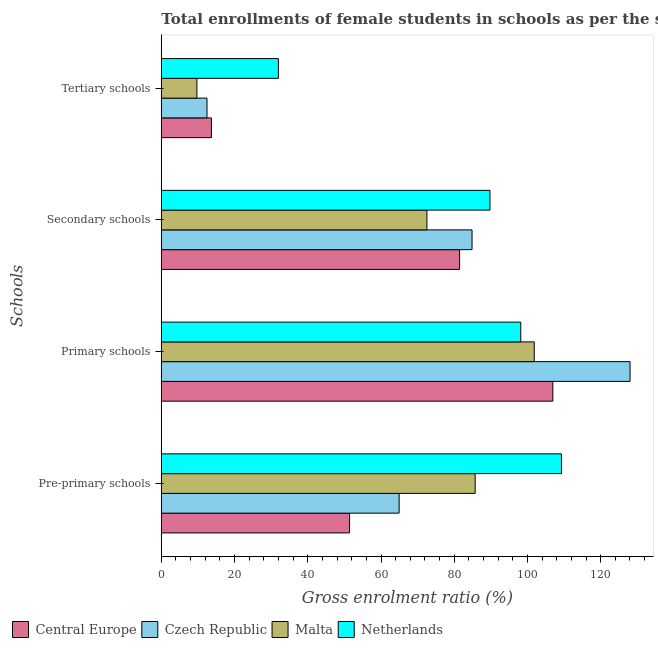How many groups of bars are there?
Give a very brief answer. 4. What is the label of the 2nd group of bars from the top?
Offer a very short reply. Secondary schools. What is the gross enrolment ratio(female) in tertiary schools in Malta?
Give a very brief answer. 9.72. Across all countries, what is the maximum gross enrolment ratio(female) in primary schools?
Provide a short and direct response. 128.02. Across all countries, what is the minimum gross enrolment ratio(female) in tertiary schools?
Provide a succinct answer. 9.72. In which country was the gross enrolment ratio(female) in primary schools maximum?
Provide a short and direct response. Czech Republic. In which country was the gross enrolment ratio(female) in pre-primary schools minimum?
Offer a terse response. Central Europe. What is the total gross enrolment ratio(female) in primary schools in the graph?
Give a very brief answer. 434.99. What is the difference between the gross enrolment ratio(female) in pre-primary schools in Netherlands and that in Malta?
Offer a terse response. 23.56. What is the difference between the gross enrolment ratio(female) in primary schools in Central Europe and the gross enrolment ratio(female) in tertiary schools in Netherlands?
Your answer should be compact. 74.96. What is the average gross enrolment ratio(female) in tertiary schools per country?
Offer a terse response. 16.96. What is the difference between the gross enrolment ratio(female) in tertiary schools and gross enrolment ratio(female) in secondary schools in Czech Republic?
Your answer should be very brief. -72.39. What is the ratio of the gross enrolment ratio(female) in primary schools in Czech Republic to that in Netherlands?
Your response must be concise. 1.3. Is the difference between the gross enrolment ratio(female) in secondary schools in Netherlands and Czech Republic greater than the difference between the gross enrolment ratio(female) in primary schools in Netherlands and Czech Republic?
Keep it short and to the point. Yes. What is the difference between the highest and the second highest gross enrolment ratio(female) in secondary schools?
Provide a short and direct response. 4.89. What is the difference between the highest and the lowest gross enrolment ratio(female) in tertiary schools?
Offer a very short reply. 22.26. In how many countries, is the gross enrolment ratio(female) in secondary schools greater than the average gross enrolment ratio(female) in secondary schools taken over all countries?
Your answer should be very brief. 2. Is the sum of the gross enrolment ratio(female) in primary schools in Czech Republic and Central Europe greater than the maximum gross enrolment ratio(female) in secondary schools across all countries?
Your response must be concise. Yes. What does the 3rd bar from the top in Tertiary schools represents?
Provide a short and direct response. Czech Republic. What does the 3rd bar from the bottom in Pre-primary schools represents?
Your answer should be compact. Malta. Is it the case that in every country, the sum of the gross enrolment ratio(female) in pre-primary schools and gross enrolment ratio(female) in primary schools is greater than the gross enrolment ratio(female) in secondary schools?
Offer a terse response. Yes. How many bars are there?
Offer a terse response. 16. Are all the bars in the graph horizontal?
Your response must be concise. Yes. How many countries are there in the graph?
Offer a very short reply. 4. What is the difference between two consecutive major ticks on the X-axis?
Ensure brevity in your answer.  20. Where does the legend appear in the graph?
Ensure brevity in your answer.  Bottom left. What is the title of the graph?
Give a very brief answer. Total enrollments of female students in schools as per the survey of 1975 conducted in different countries. Does "Bahrain" appear as one of the legend labels in the graph?
Give a very brief answer. No. What is the label or title of the Y-axis?
Provide a short and direct response. Schools. What is the Gross enrolment ratio (%) of Central Europe in Pre-primary schools?
Your response must be concise. 51.41. What is the Gross enrolment ratio (%) in Czech Republic in Pre-primary schools?
Offer a very short reply. 64.95. What is the Gross enrolment ratio (%) in Malta in Pre-primary schools?
Make the answer very short. 85.72. What is the Gross enrolment ratio (%) in Netherlands in Pre-primary schools?
Offer a very short reply. 109.28. What is the Gross enrolment ratio (%) of Central Europe in Primary schools?
Give a very brief answer. 106.94. What is the Gross enrolment ratio (%) of Czech Republic in Primary schools?
Offer a very short reply. 128.02. What is the Gross enrolment ratio (%) in Malta in Primary schools?
Ensure brevity in your answer.  101.86. What is the Gross enrolment ratio (%) in Netherlands in Primary schools?
Provide a succinct answer. 98.17. What is the Gross enrolment ratio (%) in Central Europe in Secondary schools?
Offer a terse response. 81.47. What is the Gross enrolment ratio (%) in Czech Republic in Secondary schools?
Offer a terse response. 84.86. What is the Gross enrolment ratio (%) of Malta in Secondary schools?
Provide a short and direct response. 72.54. What is the Gross enrolment ratio (%) of Netherlands in Secondary schools?
Make the answer very short. 89.75. What is the Gross enrolment ratio (%) in Central Europe in Tertiary schools?
Your answer should be very brief. 13.68. What is the Gross enrolment ratio (%) in Czech Republic in Tertiary schools?
Provide a succinct answer. 12.48. What is the Gross enrolment ratio (%) in Malta in Tertiary schools?
Offer a very short reply. 9.72. What is the Gross enrolment ratio (%) in Netherlands in Tertiary schools?
Make the answer very short. 31.98. Across all Schools, what is the maximum Gross enrolment ratio (%) in Central Europe?
Make the answer very short. 106.94. Across all Schools, what is the maximum Gross enrolment ratio (%) of Czech Republic?
Offer a very short reply. 128.02. Across all Schools, what is the maximum Gross enrolment ratio (%) of Malta?
Offer a very short reply. 101.86. Across all Schools, what is the maximum Gross enrolment ratio (%) of Netherlands?
Your response must be concise. 109.28. Across all Schools, what is the minimum Gross enrolment ratio (%) of Central Europe?
Provide a short and direct response. 13.68. Across all Schools, what is the minimum Gross enrolment ratio (%) of Czech Republic?
Offer a very short reply. 12.48. Across all Schools, what is the minimum Gross enrolment ratio (%) in Malta?
Ensure brevity in your answer.  9.72. Across all Schools, what is the minimum Gross enrolment ratio (%) of Netherlands?
Make the answer very short. 31.98. What is the total Gross enrolment ratio (%) of Central Europe in the graph?
Keep it short and to the point. 253.5. What is the total Gross enrolment ratio (%) in Czech Republic in the graph?
Your response must be concise. 290.32. What is the total Gross enrolment ratio (%) in Malta in the graph?
Your response must be concise. 269.83. What is the total Gross enrolment ratio (%) of Netherlands in the graph?
Make the answer very short. 329.19. What is the difference between the Gross enrolment ratio (%) in Central Europe in Pre-primary schools and that in Primary schools?
Give a very brief answer. -55.52. What is the difference between the Gross enrolment ratio (%) in Czech Republic in Pre-primary schools and that in Primary schools?
Offer a terse response. -63.07. What is the difference between the Gross enrolment ratio (%) of Malta in Pre-primary schools and that in Primary schools?
Keep it short and to the point. -16.14. What is the difference between the Gross enrolment ratio (%) in Netherlands in Pre-primary schools and that in Primary schools?
Ensure brevity in your answer.  11.11. What is the difference between the Gross enrolment ratio (%) of Central Europe in Pre-primary schools and that in Secondary schools?
Ensure brevity in your answer.  -30.06. What is the difference between the Gross enrolment ratio (%) in Czech Republic in Pre-primary schools and that in Secondary schools?
Ensure brevity in your answer.  -19.91. What is the difference between the Gross enrolment ratio (%) of Malta in Pre-primary schools and that in Secondary schools?
Your answer should be compact. 13.18. What is the difference between the Gross enrolment ratio (%) of Netherlands in Pre-primary schools and that in Secondary schools?
Make the answer very short. 19.53. What is the difference between the Gross enrolment ratio (%) of Central Europe in Pre-primary schools and that in Tertiary schools?
Make the answer very short. 37.74. What is the difference between the Gross enrolment ratio (%) in Czech Republic in Pre-primary schools and that in Tertiary schools?
Offer a terse response. 52.48. What is the difference between the Gross enrolment ratio (%) in Malta in Pre-primary schools and that in Tertiary schools?
Your answer should be very brief. 76. What is the difference between the Gross enrolment ratio (%) in Netherlands in Pre-primary schools and that in Tertiary schools?
Your answer should be compact. 77.3. What is the difference between the Gross enrolment ratio (%) in Central Europe in Primary schools and that in Secondary schools?
Your response must be concise. 25.46. What is the difference between the Gross enrolment ratio (%) in Czech Republic in Primary schools and that in Secondary schools?
Provide a succinct answer. 43.16. What is the difference between the Gross enrolment ratio (%) in Malta in Primary schools and that in Secondary schools?
Make the answer very short. 29.32. What is the difference between the Gross enrolment ratio (%) of Netherlands in Primary schools and that in Secondary schools?
Provide a succinct answer. 8.42. What is the difference between the Gross enrolment ratio (%) of Central Europe in Primary schools and that in Tertiary schools?
Make the answer very short. 93.26. What is the difference between the Gross enrolment ratio (%) in Czech Republic in Primary schools and that in Tertiary schools?
Your answer should be compact. 115.55. What is the difference between the Gross enrolment ratio (%) of Malta in Primary schools and that in Tertiary schools?
Ensure brevity in your answer.  92.14. What is the difference between the Gross enrolment ratio (%) of Netherlands in Primary schools and that in Tertiary schools?
Offer a very short reply. 66.19. What is the difference between the Gross enrolment ratio (%) of Central Europe in Secondary schools and that in Tertiary schools?
Ensure brevity in your answer.  67.79. What is the difference between the Gross enrolment ratio (%) of Czech Republic in Secondary schools and that in Tertiary schools?
Give a very brief answer. 72.39. What is the difference between the Gross enrolment ratio (%) of Malta in Secondary schools and that in Tertiary schools?
Provide a short and direct response. 62.82. What is the difference between the Gross enrolment ratio (%) of Netherlands in Secondary schools and that in Tertiary schools?
Keep it short and to the point. 57.77. What is the difference between the Gross enrolment ratio (%) of Central Europe in Pre-primary schools and the Gross enrolment ratio (%) of Czech Republic in Primary schools?
Your response must be concise. -76.61. What is the difference between the Gross enrolment ratio (%) of Central Europe in Pre-primary schools and the Gross enrolment ratio (%) of Malta in Primary schools?
Offer a very short reply. -50.44. What is the difference between the Gross enrolment ratio (%) of Central Europe in Pre-primary schools and the Gross enrolment ratio (%) of Netherlands in Primary schools?
Make the answer very short. -46.76. What is the difference between the Gross enrolment ratio (%) of Czech Republic in Pre-primary schools and the Gross enrolment ratio (%) of Malta in Primary schools?
Your response must be concise. -36.9. What is the difference between the Gross enrolment ratio (%) in Czech Republic in Pre-primary schools and the Gross enrolment ratio (%) in Netherlands in Primary schools?
Keep it short and to the point. -33.22. What is the difference between the Gross enrolment ratio (%) of Malta in Pre-primary schools and the Gross enrolment ratio (%) of Netherlands in Primary schools?
Offer a very short reply. -12.45. What is the difference between the Gross enrolment ratio (%) of Central Europe in Pre-primary schools and the Gross enrolment ratio (%) of Czech Republic in Secondary schools?
Your response must be concise. -33.45. What is the difference between the Gross enrolment ratio (%) in Central Europe in Pre-primary schools and the Gross enrolment ratio (%) in Malta in Secondary schools?
Keep it short and to the point. -21.13. What is the difference between the Gross enrolment ratio (%) in Central Europe in Pre-primary schools and the Gross enrolment ratio (%) in Netherlands in Secondary schools?
Offer a very short reply. -38.34. What is the difference between the Gross enrolment ratio (%) of Czech Republic in Pre-primary schools and the Gross enrolment ratio (%) of Malta in Secondary schools?
Give a very brief answer. -7.59. What is the difference between the Gross enrolment ratio (%) in Czech Republic in Pre-primary schools and the Gross enrolment ratio (%) in Netherlands in Secondary schools?
Make the answer very short. -24.8. What is the difference between the Gross enrolment ratio (%) in Malta in Pre-primary schools and the Gross enrolment ratio (%) in Netherlands in Secondary schools?
Offer a very short reply. -4.03. What is the difference between the Gross enrolment ratio (%) of Central Europe in Pre-primary schools and the Gross enrolment ratio (%) of Czech Republic in Tertiary schools?
Offer a terse response. 38.94. What is the difference between the Gross enrolment ratio (%) in Central Europe in Pre-primary schools and the Gross enrolment ratio (%) in Malta in Tertiary schools?
Your answer should be very brief. 41.7. What is the difference between the Gross enrolment ratio (%) of Central Europe in Pre-primary schools and the Gross enrolment ratio (%) of Netherlands in Tertiary schools?
Offer a very short reply. 19.43. What is the difference between the Gross enrolment ratio (%) of Czech Republic in Pre-primary schools and the Gross enrolment ratio (%) of Malta in Tertiary schools?
Offer a terse response. 55.24. What is the difference between the Gross enrolment ratio (%) in Czech Republic in Pre-primary schools and the Gross enrolment ratio (%) in Netherlands in Tertiary schools?
Ensure brevity in your answer.  32.97. What is the difference between the Gross enrolment ratio (%) in Malta in Pre-primary schools and the Gross enrolment ratio (%) in Netherlands in Tertiary schools?
Make the answer very short. 53.74. What is the difference between the Gross enrolment ratio (%) of Central Europe in Primary schools and the Gross enrolment ratio (%) of Czech Republic in Secondary schools?
Ensure brevity in your answer.  22.07. What is the difference between the Gross enrolment ratio (%) of Central Europe in Primary schools and the Gross enrolment ratio (%) of Malta in Secondary schools?
Ensure brevity in your answer.  34.4. What is the difference between the Gross enrolment ratio (%) in Central Europe in Primary schools and the Gross enrolment ratio (%) in Netherlands in Secondary schools?
Ensure brevity in your answer.  17.18. What is the difference between the Gross enrolment ratio (%) in Czech Republic in Primary schools and the Gross enrolment ratio (%) in Malta in Secondary schools?
Offer a terse response. 55.48. What is the difference between the Gross enrolment ratio (%) in Czech Republic in Primary schools and the Gross enrolment ratio (%) in Netherlands in Secondary schools?
Offer a very short reply. 38.27. What is the difference between the Gross enrolment ratio (%) of Malta in Primary schools and the Gross enrolment ratio (%) of Netherlands in Secondary schools?
Make the answer very short. 12.1. What is the difference between the Gross enrolment ratio (%) of Central Europe in Primary schools and the Gross enrolment ratio (%) of Czech Republic in Tertiary schools?
Offer a terse response. 94.46. What is the difference between the Gross enrolment ratio (%) of Central Europe in Primary schools and the Gross enrolment ratio (%) of Malta in Tertiary schools?
Offer a very short reply. 97.22. What is the difference between the Gross enrolment ratio (%) of Central Europe in Primary schools and the Gross enrolment ratio (%) of Netherlands in Tertiary schools?
Your response must be concise. 74.96. What is the difference between the Gross enrolment ratio (%) in Czech Republic in Primary schools and the Gross enrolment ratio (%) in Malta in Tertiary schools?
Offer a terse response. 118.31. What is the difference between the Gross enrolment ratio (%) of Czech Republic in Primary schools and the Gross enrolment ratio (%) of Netherlands in Tertiary schools?
Provide a short and direct response. 96.04. What is the difference between the Gross enrolment ratio (%) of Malta in Primary schools and the Gross enrolment ratio (%) of Netherlands in Tertiary schools?
Offer a terse response. 69.88. What is the difference between the Gross enrolment ratio (%) in Central Europe in Secondary schools and the Gross enrolment ratio (%) in Czech Republic in Tertiary schools?
Your answer should be very brief. 68.99. What is the difference between the Gross enrolment ratio (%) of Central Europe in Secondary schools and the Gross enrolment ratio (%) of Malta in Tertiary schools?
Make the answer very short. 71.76. What is the difference between the Gross enrolment ratio (%) in Central Europe in Secondary schools and the Gross enrolment ratio (%) in Netherlands in Tertiary schools?
Offer a terse response. 49.49. What is the difference between the Gross enrolment ratio (%) of Czech Republic in Secondary schools and the Gross enrolment ratio (%) of Malta in Tertiary schools?
Provide a short and direct response. 75.15. What is the difference between the Gross enrolment ratio (%) of Czech Republic in Secondary schools and the Gross enrolment ratio (%) of Netherlands in Tertiary schools?
Offer a very short reply. 52.88. What is the difference between the Gross enrolment ratio (%) in Malta in Secondary schools and the Gross enrolment ratio (%) in Netherlands in Tertiary schools?
Provide a succinct answer. 40.56. What is the average Gross enrolment ratio (%) in Central Europe per Schools?
Ensure brevity in your answer.  63.38. What is the average Gross enrolment ratio (%) in Czech Republic per Schools?
Give a very brief answer. 72.58. What is the average Gross enrolment ratio (%) in Malta per Schools?
Your response must be concise. 67.46. What is the average Gross enrolment ratio (%) of Netherlands per Schools?
Provide a succinct answer. 82.3. What is the difference between the Gross enrolment ratio (%) of Central Europe and Gross enrolment ratio (%) of Czech Republic in Pre-primary schools?
Give a very brief answer. -13.54. What is the difference between the Gross enrolment ratio (%) of Central Europe and Gross enrolment ratio (%) of Malta in Pre-primary schools?
Offer a very short reply. -34.31. What is the difference between the Gross enrolment ratio (%) in Central Europe and Gross enrolment ratio (%) in Netherlands in Pre-primary schools?
Provide a short and direct response. -57.87. What is the difference between the Gross enrolment ratio (%) in Czech Republic and Gross enrolment ratio (%) in Malta in Pre-primary schools?
Keep it short and to the point. -20.77. What is the difference between the Gross enrolment ratio (%) in Czech Republic and Gross enrolment ratio (%) in Netherlands in Pre-primary schools?
Offer a terse response. -44.33. What is the difference between the Gross enrolment ratio (%) in Malta and Gross enrolment ratio (%) in Netherlands in Pre-primary schools?
Ensure brevity in your answer.  -23.56. What is the difference between the Gross enrolment ratio (%) in Central Europe and Gross enrolment ratio (%) in Czech Republic in Primary schools?
Give a very brief answer. -21.09. What is the difference between the Gross enrolment ratio (%) in Central Europe and Gross enrolment ratio (%) in Malta in Primary schools?
Your answer should be very brief. 5.08. What is the difference between the Gross enrolment ratio (%) of Central Europe and Gross enrolment ratio (%) of Netherlands in Primary schools?
Provide a succinct answer. 8.76. What is the difference between the Gross enrolment ratio (%) in Czech Republic and Gross enrolment ratio (%) in Malta in Primary schools?
Offer a very short reply. 26.17. What is the difference between the Gross enrolment ratio (%) in Czech Republic and Gross enrolment ratio (%) in Netherlands in Primary schools?
Your answer should be very brief. 29.85. What is the difference between the Gross enrolment ratio (%) in Malta and Gross enrolment ratio (%) in Netherlands in Primary schools?
Keep it short and to the point. 3.69. What is the difference between the Gross enrolment ratio (%) of Central Europe and Gross enrolment ratio (%) of Czech Republic in Secondary schools?
Provide a succinct answer. -3.39. What is the difference between the Gross enrolment ratio (%) in Central Europe and Gross enrolment ratio (%) in Malta in Secondary schools?
Offer a terse response. 8.93. What is the difference between the Gross enrolment ratio (%) of Central Europe and Gross enrolment ratio (%) of Netherlands in Secondary schools?
Provide a succinct answer. -8.28. What is the difference between the Gross enrolment ratio (%) of Czech Republic and Gross enrolment ratio (%) of Malta in Secondary schools?
Provide a short and direct response. 12.32. What is the difference between the Gross enrolment ratio (%) of Czech Republic and Gross enrolment ratio (%) of Netherlands in Secondary schools?
Offer a terse response. -4.89. What is the difference between the Gross enrolment ratio (%) of Malta and Gross enrolment ratio (%) of Netherlands in Secondary schools?
Provide a succinct answer. -17.21. What is the difference between the Gross enrolment ratio (%) in Central Europe and Gross enrolment ratio (%) in Czech Republic in Tertiary schools?
Provide a short and direct response. 1.2. What is the difference between the Gross enrolment ratio (%) of Central Europe and Gross enrolment ratio (%) of Malta in Tertiary schools?
Offer a terse response. 3.96. What is the difference between the Gross enrolment ratio (%) in Central Europe and Gross enrolment ratio (%) in Netherlands in Tertiary schools?
Your answer should be very brief. -18.3. What is the difference between the Gross enrolment ratio (%) of Czech Republic and Gross enrolment ratio (%) of Malta in Tertiary schools?
Give a very brief answer. 2.76. What is the difference between the Gross enrolment ratio (%) in Czech Republic and Gross enrolment ratio (%) in Netherlands in Tertiary schools?
Provide a short and direct response. -19.5. What is the difference between the Gross enrolment ratio (%) of Malta and Gross enrolment ratio (%) of Netherlands in Tertiary schools?
Your answer should be compact. -22.26. What is the ratio of the Gross enrolment ratio (%) in Central Europe in Pre-primary schools to that in Primary schools?
Give a very brief answer. 0.48. What is the ratio of the Gross enrolment ratio (%) in Czech Republic in Pre-primary schools to that in Primary schools?
Offer a terse response. 0.51. What is the ratio of the Gross enrolment ratio (%) of Malta in Pre-primary schools to that in Primary schools?
Your response must be concise. 0.84. What is the ratio of the Gross enrolment ratio (%) in Netherlands in Pre-primary schools to that in Primary schools?
Ensure brevity in your answer.  1.11. What is the ratio of the Gross enrolment ratio (%) in Central Europe in Pre-primary schools to that in Secondary schools?
Give a very brief answer. 0.63. What is the ratio of the Gross enrolment ratio (%) of Czech Republic in Pre-primary schools to that in Secondary schools?
Provide a succinct answer. 0.77. What is the ratio of the Gross enrolment ratio (%) of Malta in Pre-primary schools to that in Secondary schools?
Provide a succinct answer. 1.18. What is the ratio of the Gross enrolment ratio (%) in Netherlands in Pre-primary schools to that in Secondary schools?
Ensure brevity in your answer.  1.22. What is the ratio of the Gross enrolment ratio (%) in Central Europe in Pre-primary schools to that in Tertiary schools?
Your answer should be compact. 3.76. What is the ratio of the Gross enrolment ratio (%) of Czech Republic in Pre-primary schools to that in Tertiary schools?
Your response must be concise. 5.21. What is the ratio of the Gross enrolment ratio (%) of Malta in Pre-primary schools to that in Tertiary schools?
Give a very brief answer. 8.82. What is the ratio of the Gross enrolment ratio (%) of Netherlands in Pre-primary schools to that in Tertiary schools?
Your answer should be very brief. 3.42. What is the ratio of the Gross enrolment ratio (%) of Central Europe in Primary schools to that in Secondary schools?
Offer a very short reply. 1.31. What is the ratio of the Gross enrolment ratio (%) in Czech Republic in Primary schools to that in Secondary schools?
Keep it short and to the point. 1.51. What is the ratio of the Gross enrolment ratio (%) in Malta in Primary schools to that in Secondary schools?
Your answer should be very brief. 1.4. What is the ratio of the Gross enrolment ratio (%) in Netherlands in Primary schools to that in Secondary schools?
Provide a succinct answer. 1.09. What is the ratio of the Gross enrolment ratio (%) of Central Europe in Primary schools to that in Tertiary schools?
Give a very brief answer. 7.82. What is the ratio of the Gross enrolment ratio (%) in Czech Republic in Primary schools to that in Tertiary schools?
Make the answer very short. 10.26. What is the ratio of the Gross enrolment ratio (%) of Malta in Primary schools to that in Tertiary schools?
Offer a terse response. 10.48. What is the ratio of the Gross enrolment ratio (%) of Netherlands in Primary schools to that in Tertiary schools?
Offer a very short reply. 3.07. What is the ratio of the Gross enrolment ratio (%) in Central Europe in Secondary schools to that in Tertiary schools?
Make the answer very short. 5.96. What is the ratio of the Gross enrolment ratio (%) of Czech Republic in Secondary schools to that in Tertiary schools?
Provide a short and direct response. 6.8. What is the ratio of the Gross enrolment ratio (%) in Malta in Secondary schools to that in Tertiary schools?
Keep it short and to the point. 7.46. What is the ratio of the Gross enrolment ratio (%) in Netherlands in Secondary schools to that in Tertiary schools?
Keep it short and to the point. 2.81. What is the difference between the highest and the second highest Gross enrolment ratio (%) of Central Europe?
Provide a succinct answer. 25.46. What is the difference between the highest and the second highest Gross enrolment ratio (%) in Czech Republic?
Your response must be concise. 43.16. What is the difference between the highest and the second highest Gross enrolment ratio (%) in Malta?
Offer a very short reply. 16.14. What is the difference between the highest and the second highest Gross enrolment ratio (%) of Netherlands?
Ensure brevity in your answer.  11.11. What is the difference between the highest and the lowest Gross enrolment ratio (%) in Central Europe?
Ensure brevity in your answer.  93.26. What is the difference between the highest and the lowest Gross enrolment ratio (%) of Czech Republic?
Your answer should be compact. 115.55. What is the difference between the highest and the lowest Gross enrolment ratio (%) in Malta?
Provide a short and direct response. 92.14. What is the difference between the highest and the lowest Gross enrolment ratio (%) in Netherlands?
Keep it short and to the point. 77.3. 